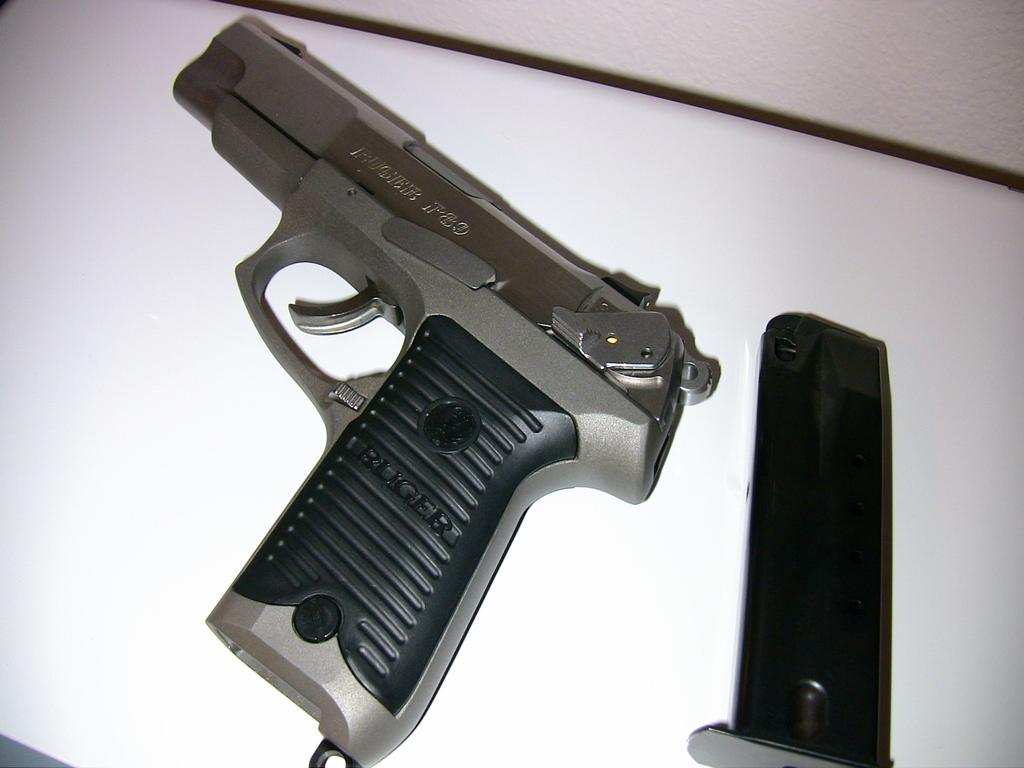What type of weapon is present in the image? There is a gun in the image. What is the ammunition source for the gun? There is a magazine in the image. Can you describe the object on the platform? The object is not specified, but it is on a platform. How many chickens are swimming in the boats in the image? There are no chickens or boats present in the image. What type of teeth can be seen on the object in the image? There is no mention of teeth in the image, and the object's description is not provided. 